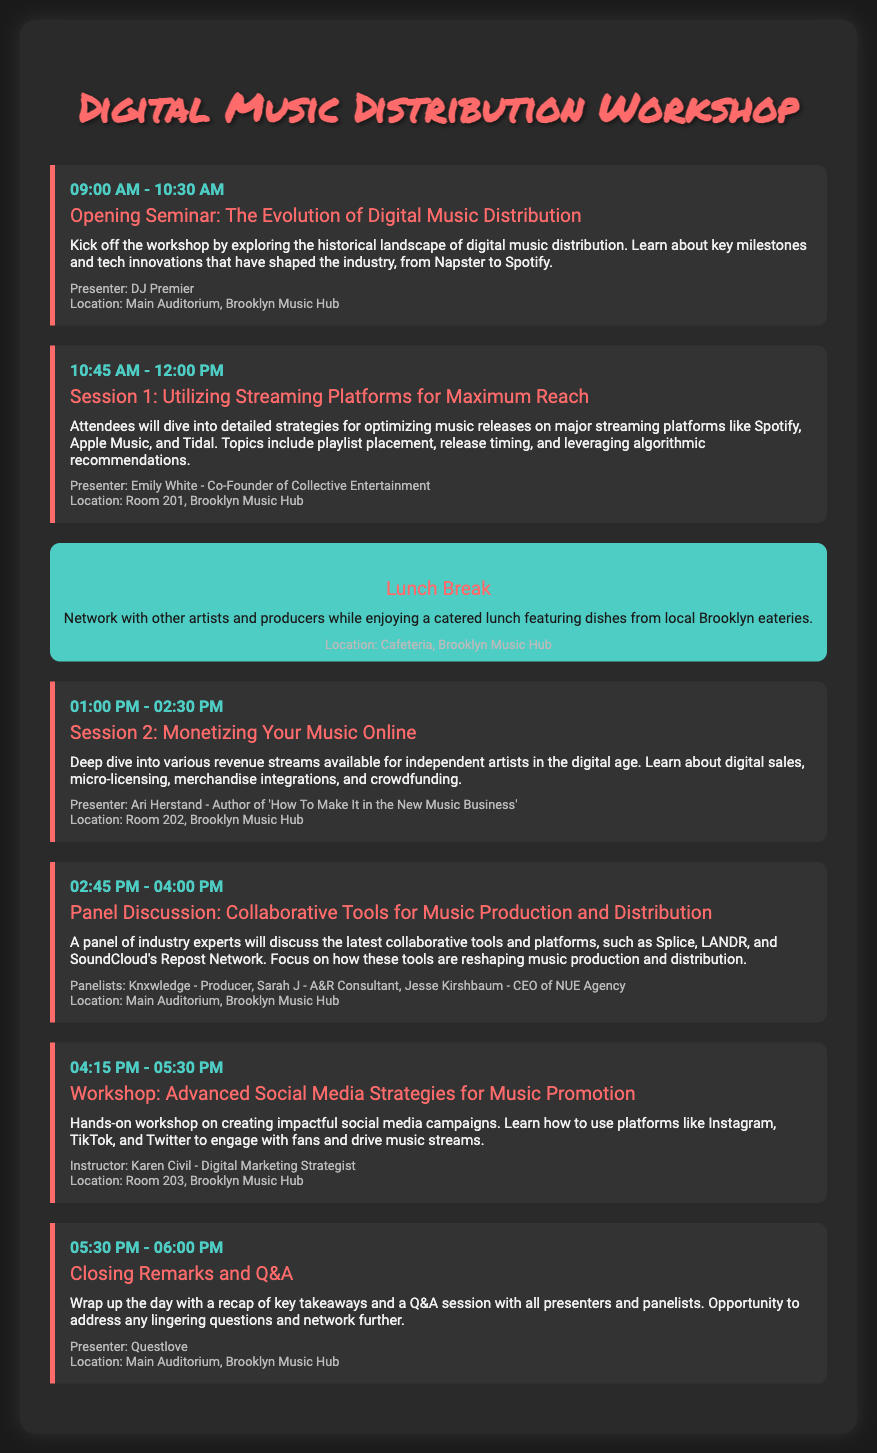what time does the workshop start? The workshop starts at 09:00 AM, as indicated in the opening event's details.
Answer: 09:00 AM who is the presenter for the closing remarks? The presenter for the closing remarks is Questlove, as mentioned in the event details.
Answer: Questlove what is the location of Session 1? Session 1 takes place in Room 201, as stated in the location section of the event.
Answer: Room 201 how long is the lunch break? The lunch break is one hour long, which is specified in the timing of the event.
Answer: 01:00 which presenter is associated with the panel discussion? The panel discussion includes multiple panelists, with Knxwledge being one of them as per the event description.
Answer: Knxwledge how many sessions are there in total? There are five sessions and workshops listed in the document, including the opening seminar and closing remarks.
Answer: 5 what is the main topic of Session 2? Session 2 focuses on monetizing music online, according to the description provided.
Answer: Monetizing Your Music Online which platform is discussed for collaborative tools? Platforms such as Splice, LANDR, and SoundCloud's Repost Network are highlighted in the panel discussion.
Answer: Splice what time does the last event end? The last event, which includes closing remarks and Q&A, ends at 06:00 PM as listed in its time details.
Answer: 06:00 PM 